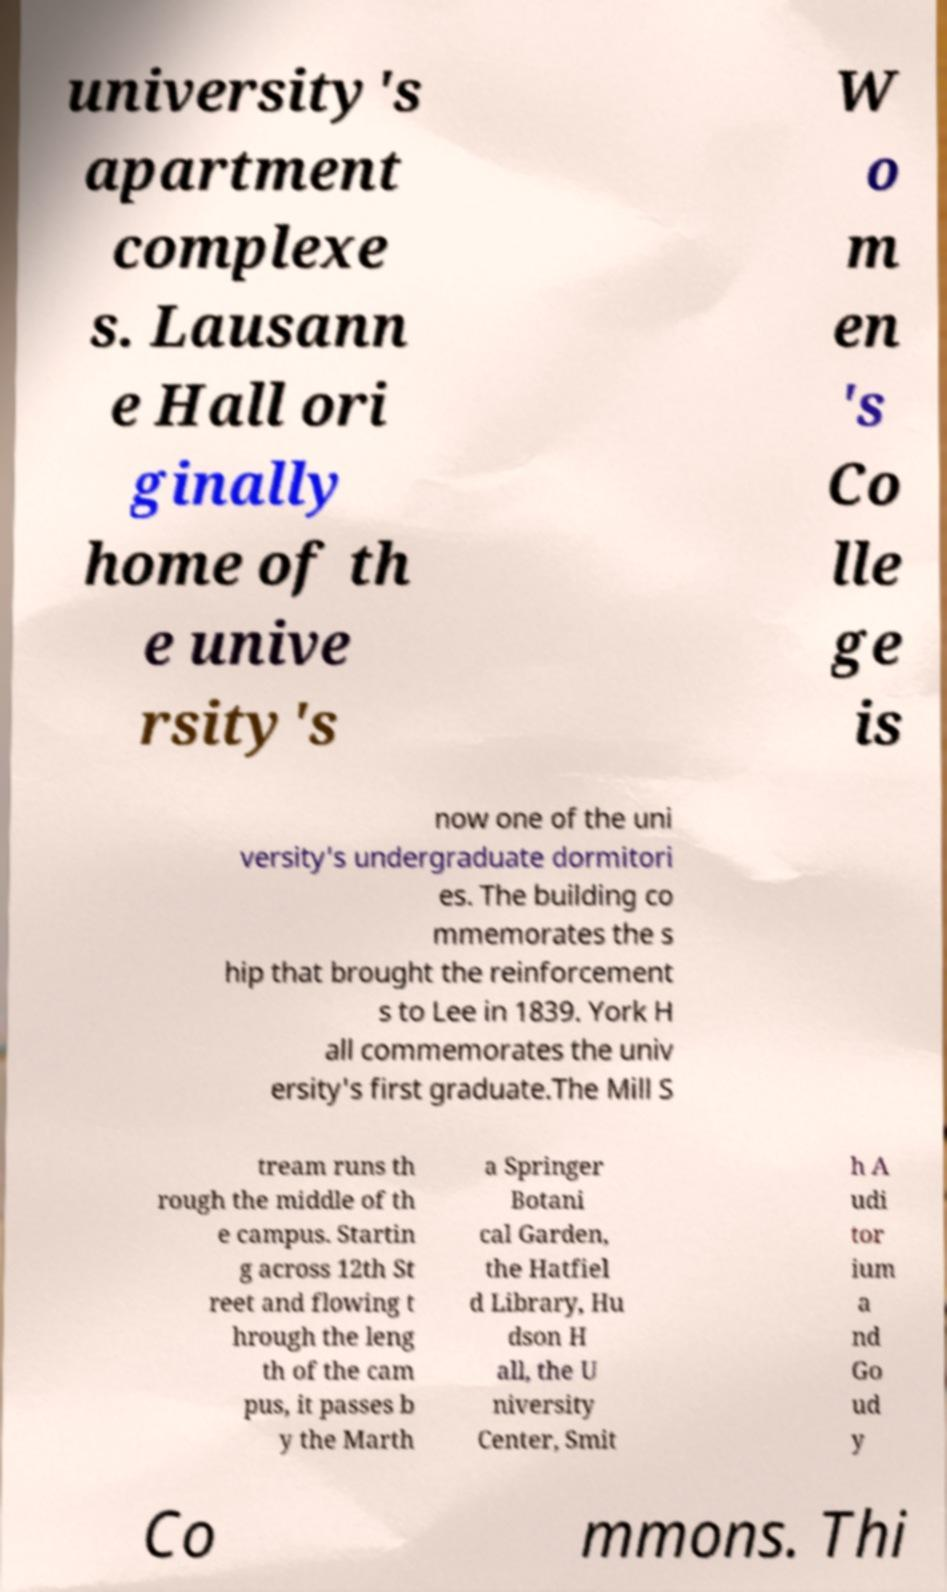Could you extract and type out the text from this image? university's apartment complexe s. Lausann e Hall ori ginally home of th e unive rsity's W o m en 's Co lle ge is now one of the uni versity's undergraduate dormitori es. The building co mmemorates the s hip that brought the reinforcement s to Lee in 1839. York H all commemorates the univ ersity's first graduate.The Mill S tream runs th rough the middle of th e campus. Startin g across 12th St reet and flowing t hrough the leng th of the cam pus, it passes b y the Marth a Springer Botani cal Garden, the Hatfiel d Library, Hu dson H all, the U niversity Center, Smit h A udi tor ium a nd Go ud y Co mmons. Thi 